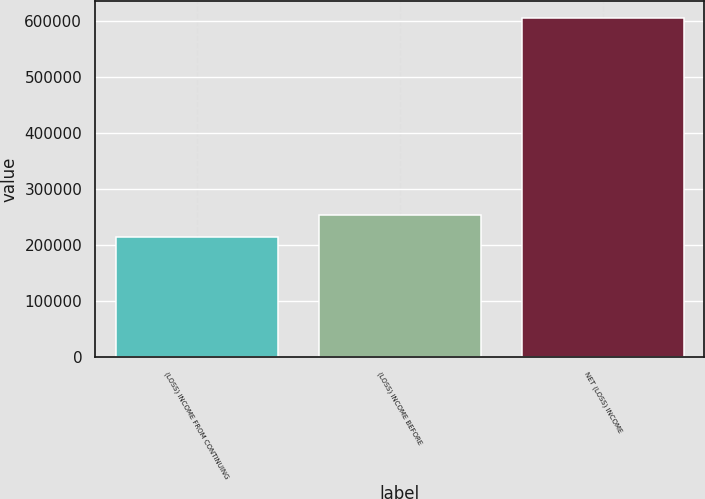Convert chart. <chart><loc_0><loc_0><loc_500><loc_500><bar_chart><fcel>(LOSS) INCOME FROM CONTINUING<fcel>(LOSS) INCOME BEFORE<fcel>NET (LOSS) INCOME<nl><fcel>214715<fcel>253875<fcel>606319<nl></chart> 